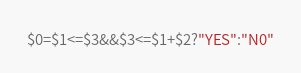<code> <loc_0><loc_0><loc_500><loc_500><_Awk_>$0=$1<=$3&&$3<=$1+$2?"YES":"N0"</code> 